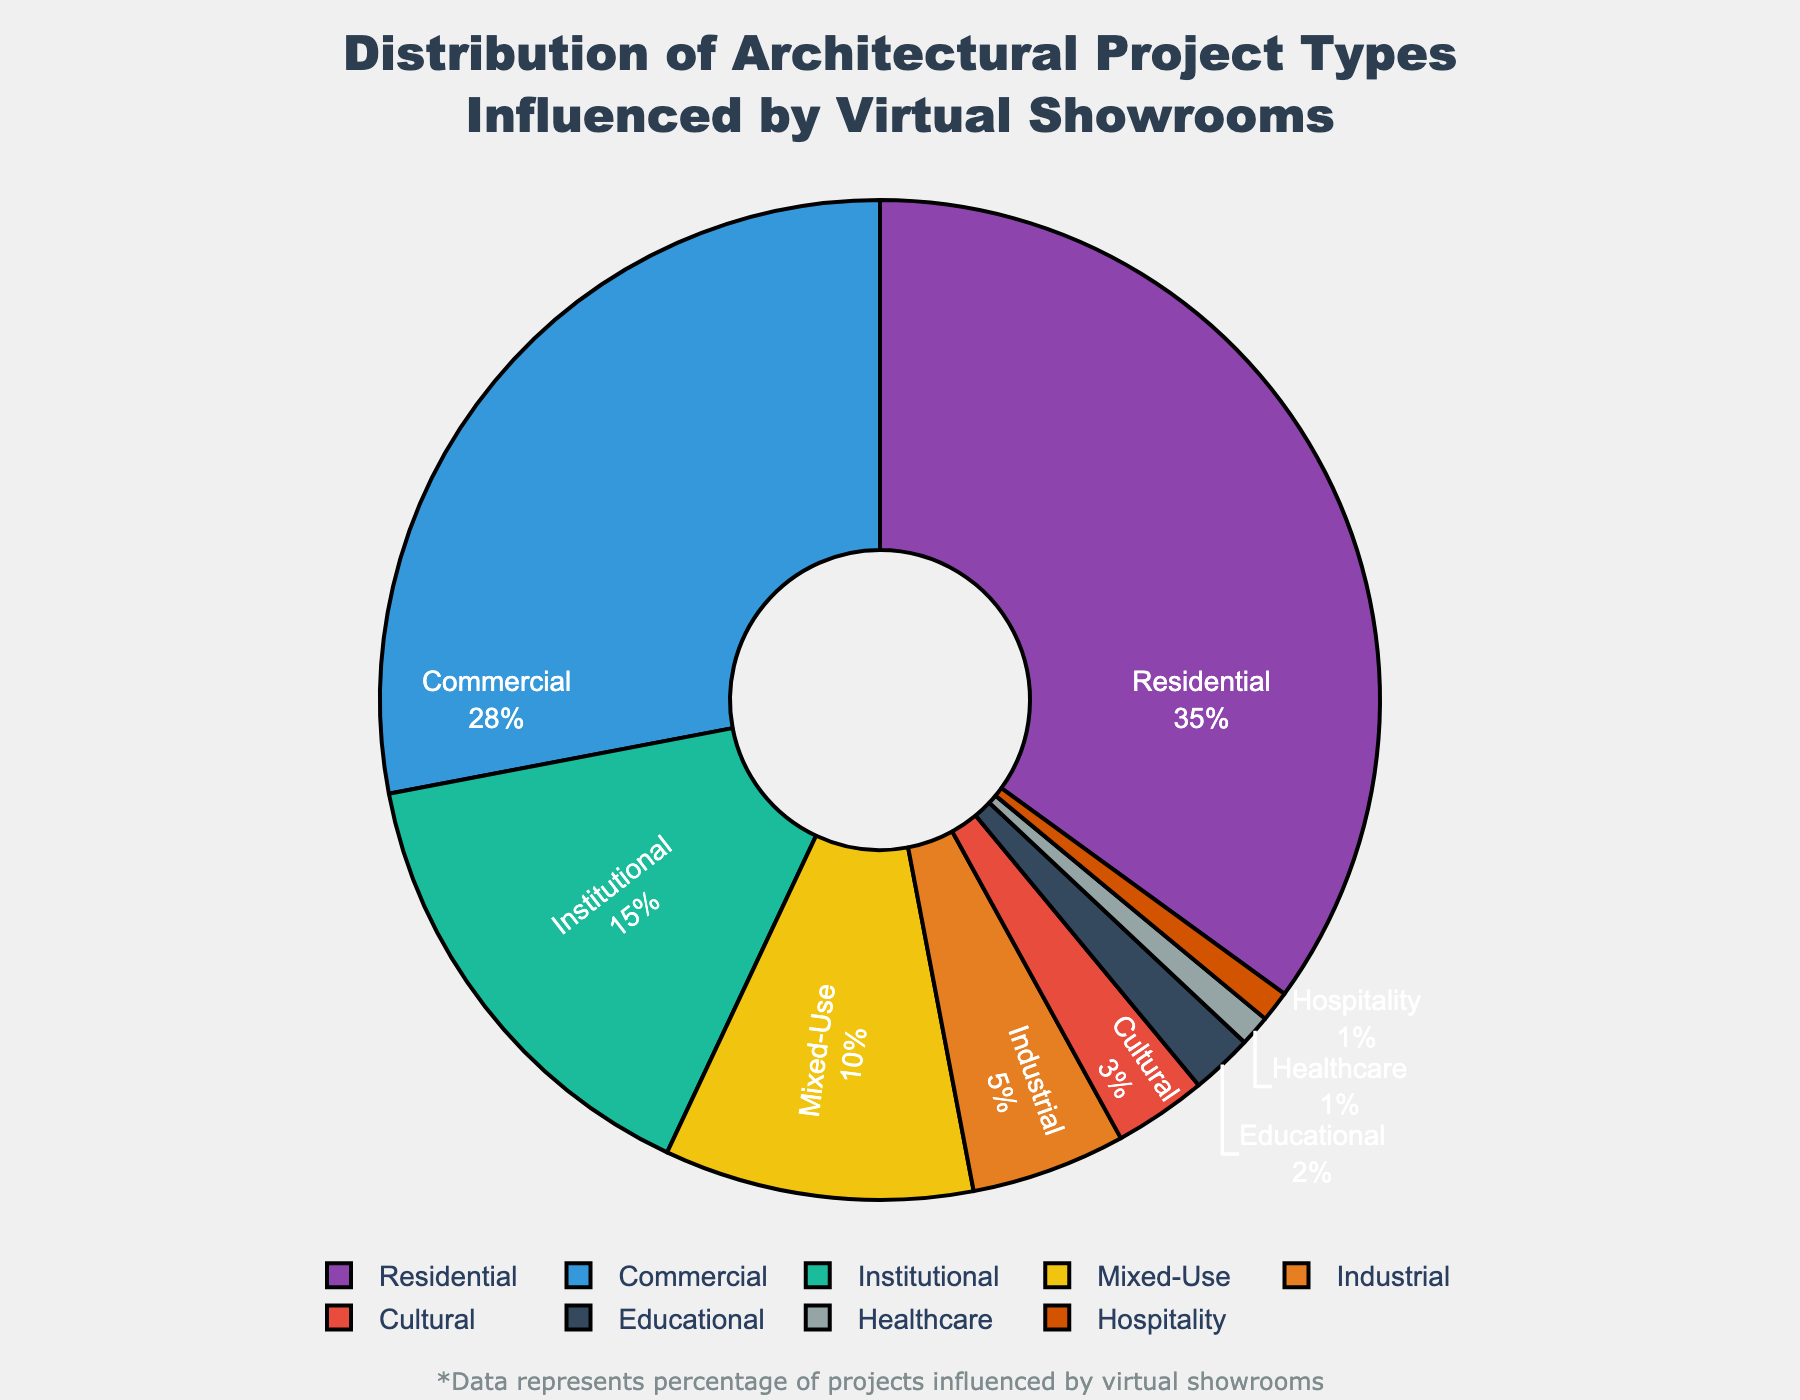What percentage of architectural projects influenced by virtual showrooms are residential? The residential projects take up a section of the pie chart labeled "Residential," which shows the percentage clearly.
Answer: 35% What is the combined percentage of commercial and institutional projects influenced by virtual showrooms? Add the percentages for "Commercial" and "Institutional" projects: 28% + 15% = 43%.
Answer: 43% Which project type has the smallest influence from virtual showrooms? Look for the project type with the smallest percentage slice in the pie chart, which is clearly labeled.
Answer: Hospitality How does the percentage of mixed-use projects compare to industrial projects? Compare the percentages shown for "Mixed-Use" (10%) and "Industrial" (5%). Mixed-Use is greater than Industrial.
Answer: Mixed-Use is greater What is the total percentage of cultural, educational, healthcare, and hospitality projects combined? Sum the percentages for "Cultural" (3%), "Educational" (2%), "Healthcare" (1%), and "Hospitality" (1%): 3% + 2% + 1% + 1% = 7%.
Answer: 7% Is the percentage of commercial projects greater than the percentage of residential projects? Compare the percentage slices: Residential is 35% and Commercial is 28%. Residential is greater than Commercial.
Answer: No What is the difference between the highest and the lowest percentage of project types influenced by virtual showrooms? Subtract the smallest percentage (Hospitality, 1%) from the largest percentage (Residential, 35%): 35% - 1% = 34%.
Answer: 34% Are institutional projects influenced by virtual showrooms more than twice as much as mixed-use projects? Compare twice the percentage of Mixed-Use (2 * 10% = 20%) with the percentage for Institutional (15%). 15% is less than 20%.
Answer: No Which project type(s) have a percentage less than 5%? Find the slices with percentages less than 5%: "Cultural," "Educational," "Healthcare," and "Hospitality."
Answer: Cultural, Educational, Healthcare, Hospitality What is the average percentage of residential, commercial, and institutional projects influenced by virtual showrooms? Calculate the average: (35% + 28% + 15%) / 3 = 26%.
Answer: 26% 